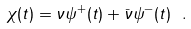<formula> <loc_0><loc_0><loc_500><loc_500>\chi ( t ) = \nu \psi ^ { + } ( t ) + \bar { \nu } \psi ^ { - } ( t ) \ .</formula> 